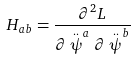Convert formula to latex. <formula><loc_0><loc_0><loc_500><loc_500>H _ { a b } = \frac { \partial ^ { 2 } L } { \partial \stackrel { . . } { \psi } ^ { a } \partial \stackrel { . . } { \psi } ^ { b } }</formula> 